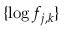<formula> <loc_0><loc_0><loc_500><loc_500>\{ \log f _ { j , k } \}</formula> 